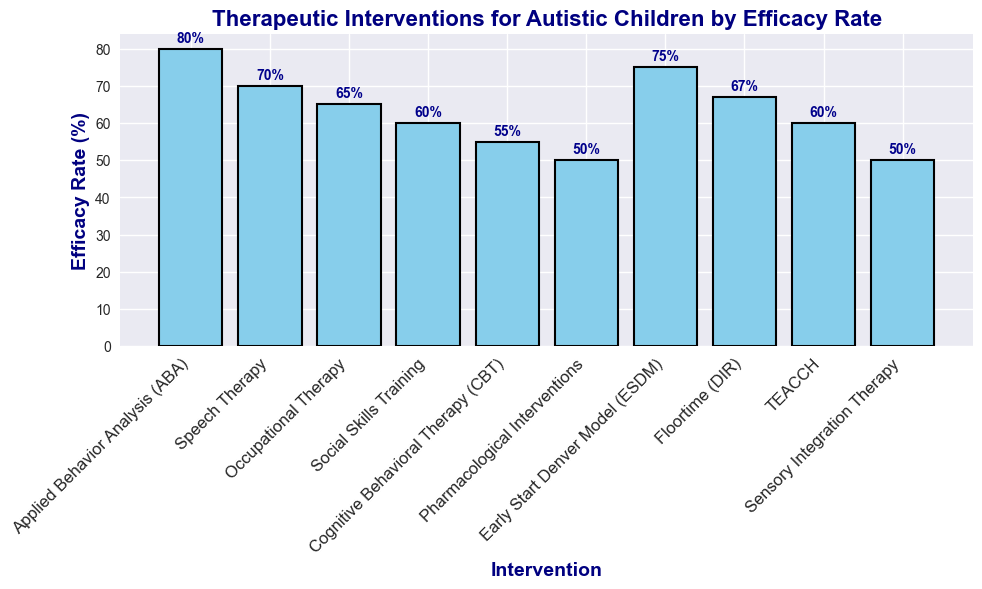Which intervention has the highest efficacy rate? The highest bar represents the highest efficacy rate. It is labeled "Applied Behavior Analysis (ABA)" with an efficacy rate of 80%.
Answer: Applied Behavior Analysis (ABA) What is the difference in efficacy rate between Speech Therapy and Cognitive Behavioral Therapy (CBT)? The efficacy rate for Speech Therapy is 70% and for Cognitive Behavioral Therapy (CBT) is 55%. Subtracting the latter from the former gives 70% - 55% = 15%.
Answer: 15% Which intervention has a lower efficacy rate, TEACCH or Social Skills Training? By comparing the heights of the bars labeled "TEACCH" and "Social Skills Training", TEACCH and Social Skills Training both have identical efficacy rates of 60%. Consequently, neither is lower.
Answer: Neither What is the combined efficacy rate of the two least effective interventions? The two least effective interventions are Pharmacological Interventions and Sensory Integration Therapy, each with an efficacy rate of 50%. Combined, it is 50% + 50% = 100%.
Answer: 100% How many interventions have an efficacy rate higher than 65%? The labels of the bars that have heights higher than 65% are Applied Behavior Analysis (ABA), Speech Therapy, Early Start Denver Model (ESDM), and Floortime (DIR). This counts to four interventions.
Answer: 4 Between Early Start Denver Model (ESDM) and Floortime (DIR), which one is more effective? Comparing the heights of the bars labeled "Early Start Denver Model (ESDM)" (75%) and "Floortime (DIR)" (67%), Early Start Denver Model (ESDM) has a higher efficacy rate.
Answer: Early Start Denver Model (ESDM) What is the average efficacy rate of the interventions that have rates above 60%? Interventions with rates above 60% are Applied Behavior Analysis (ABA) (80%), Speech Therapy (70%), Early Start Denver Model (ESDM) (75%), and Floortime (DIR) (67%). The average is calculated as (80 + 70 + 75 + 67) / 4 = 73%.
Answer: 73% If we exclude the most effective intervention, what is the new median efficacy rate? Excluding Applied Behavior Analysis (ABA) (80%), the efficacy rates are 70, 65, 60, 60, 55, 50, 75, 67, 50. Ordered: 50, 50, 55, 60, 60, 65, 67, 70, 75. The median is the middle value, which is 60%.
Answer: 60% What is the range of efficacy rates for the listed interventions? The highest efficacy rate is 80% (Applied Behavior Analysis (ABA)) and the lowest is 50% (Pharmacological Interventions and Sensory Integration Therapy). The range is calculated as 80% - 50% = 30%.
Answer: 30% 